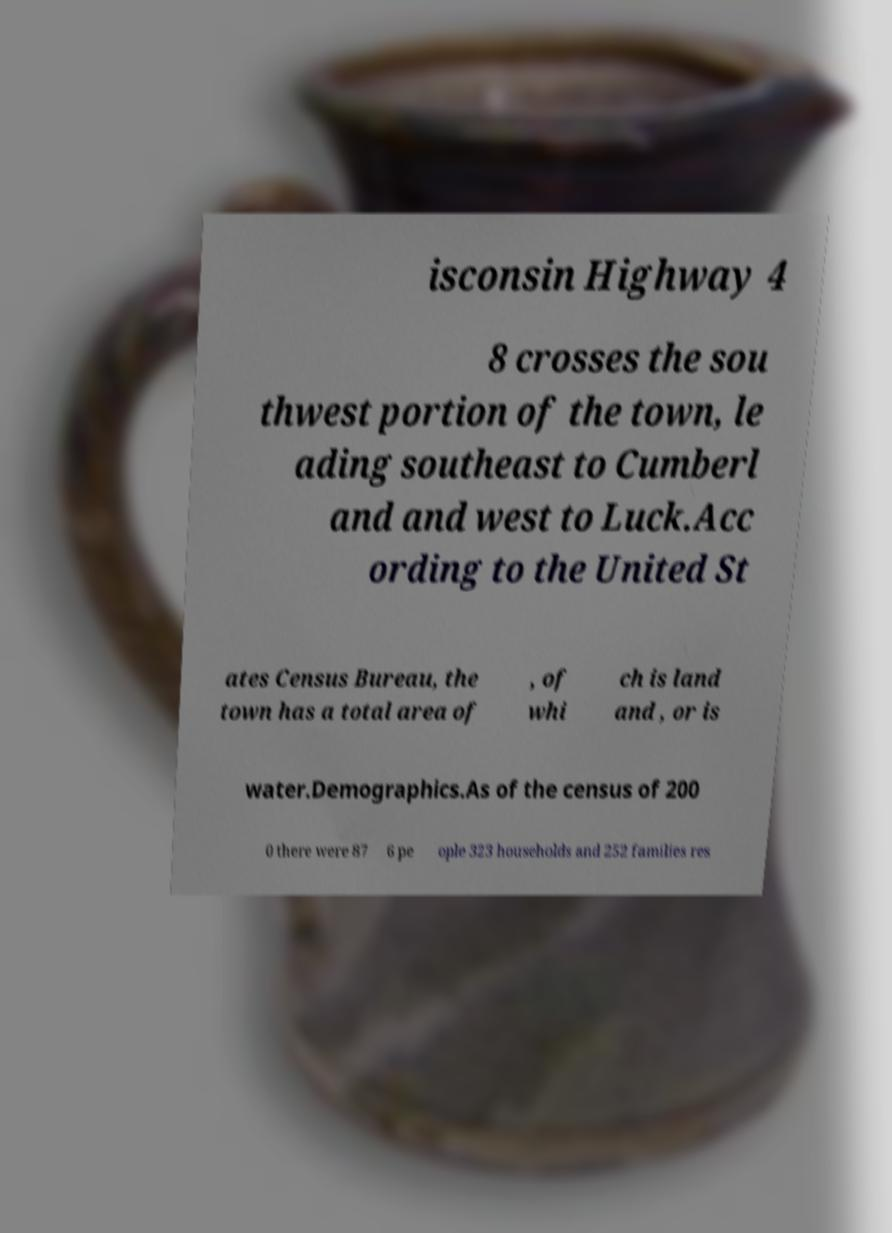Please read and relay the text visible in this image. What does it say? isconsin Highway 4 8 crosses the sou thwest portion of the town, le ading southeast to Cumberl and and west to Luck.Acc ording to the United St ates Census Bureau, the town has a total area of , of whi ch is land and , or is water.Demographics.As of the census of 200 0 there were 87 6 pe ople 323 households and 252 families res 